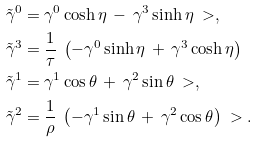Convert formula to latex. <formula><loc_0><loc_0><loc_500><loc_500>\tilde { \gamma } ^ { 0 } = & \ \gamma ^ { 0 } \cosh \eta \, - \, \gamma ^ { 3 } \sinh \eta \ > , \\ \tilde { \gamma } ^ { 3 } = & \ \frac { 1 } { \tau } \ \left ( - \gamma ^ { 0 } \sinh \eta \, + \, \gamma ^ { 3 } \cosh \eta \right ) \\ \tilde { \gamma } ^ { 1 } = & \ \gamma ^ { 1 } \cos \theta \, + \, \gamma ^ { 2 } \sin \theta \ > , \\ \tilde { \gamma } ^ { 2 } = & \ \frac { 1 } { \rho } \ \left ( - \gamma ^ { 1 } \sin \theta \, + \, \gamma ^ { 2 } \cos \theta \right ) \ > .</formula> 